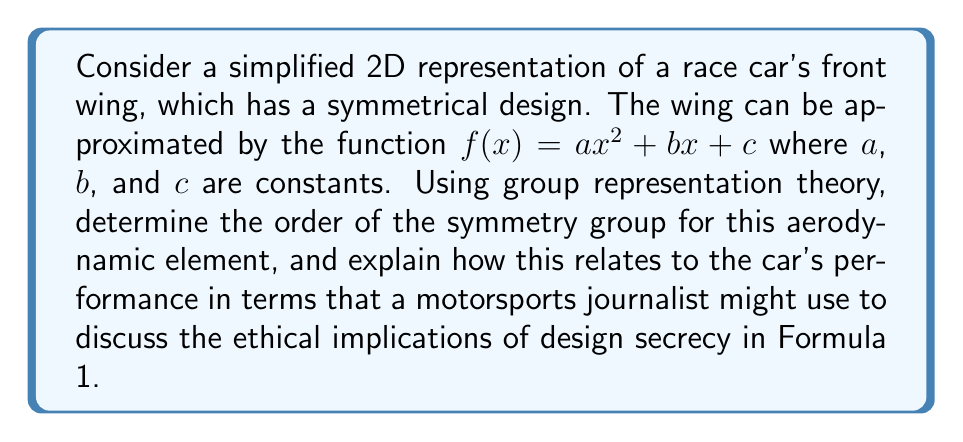Can you answer this question? 1. First, let's identify the symmetries of the parabolic function $f(x) = ax^2 + bx + c$:
   - Reflection about the y-axis (when $b = 0$)
   - Identity transformation

2. These symmetries form a group isomorphic to $C_2$, the cyclic group of order 2.

3. The representation of this group on the function space can be described as:
   $$\rho: C_2 \to GL(V)$$
   where $V$ is the vector space of quadratic functions.

4. The character of this representation is:
   $$\chi(e) = 3$$ (dimension of the space of quadratic functions)
   $$\chi(r) = 1$$ (only $ax^2 + c$ terms are invariant under reflection)

5. The order of the symmetry group is determined by the number of elements in $C_2$, which is 2.

6. In motorsports context:
   - The symmetry of the wing design contributes to balanced aerodynamic performance.
   - Teams often keep their aerodynamic designs secret to maintain competitive advantage.
   - This secrecy can be viewed through an ethical lens, considering fairness in competition and the spirit of innovation in the sport.
   - The simplicity of the symmetry group (order 2) suggests a basic design principle that balances performance and regulatory compliance.
Answer: The order of the symmetry group is 2. 